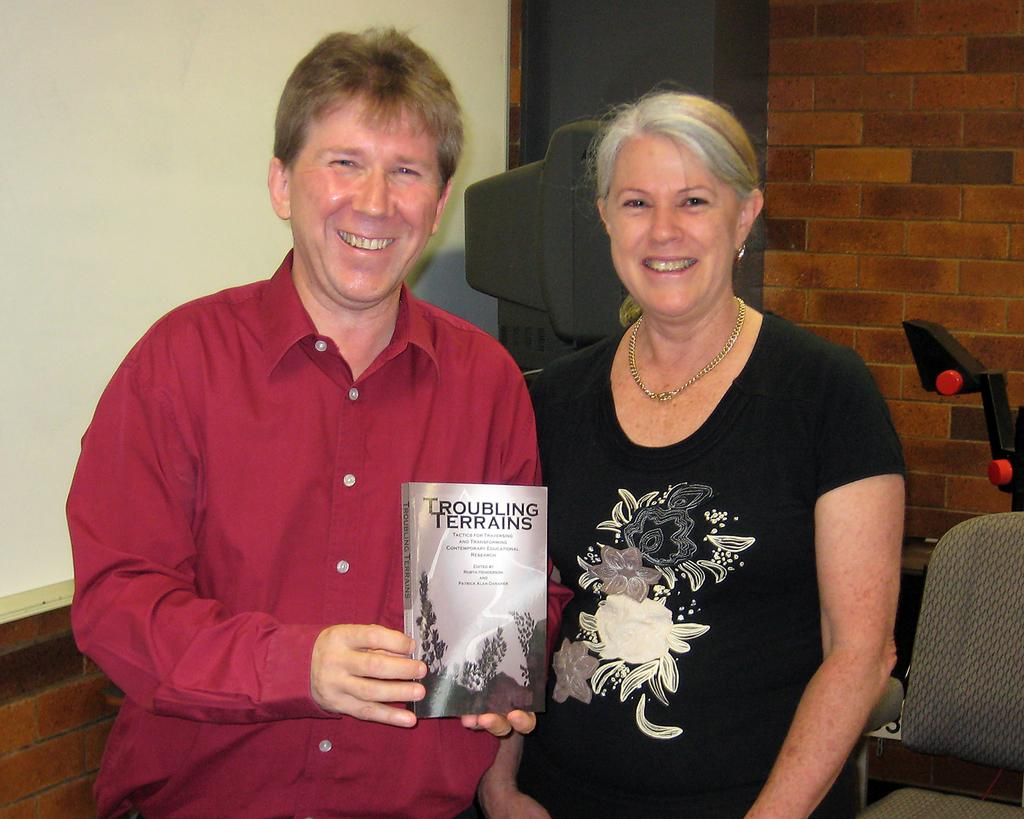How many people are in the image? There are two people in the image. What is one of the people doing? One of the people is holding a book. What piece of furniture is in the image? There is a chair in the image. What else can be seen in the image besides the people and the chair? There are other objects in the image. What is the background of the image? There is a wall visible in the image. What type of island is visible in the image? There is no island present in the image. What is the opinion of the person holding the book about the objects in the image? The facts provided do not give us any information about the person's opinion, so we cannot answer this question. 